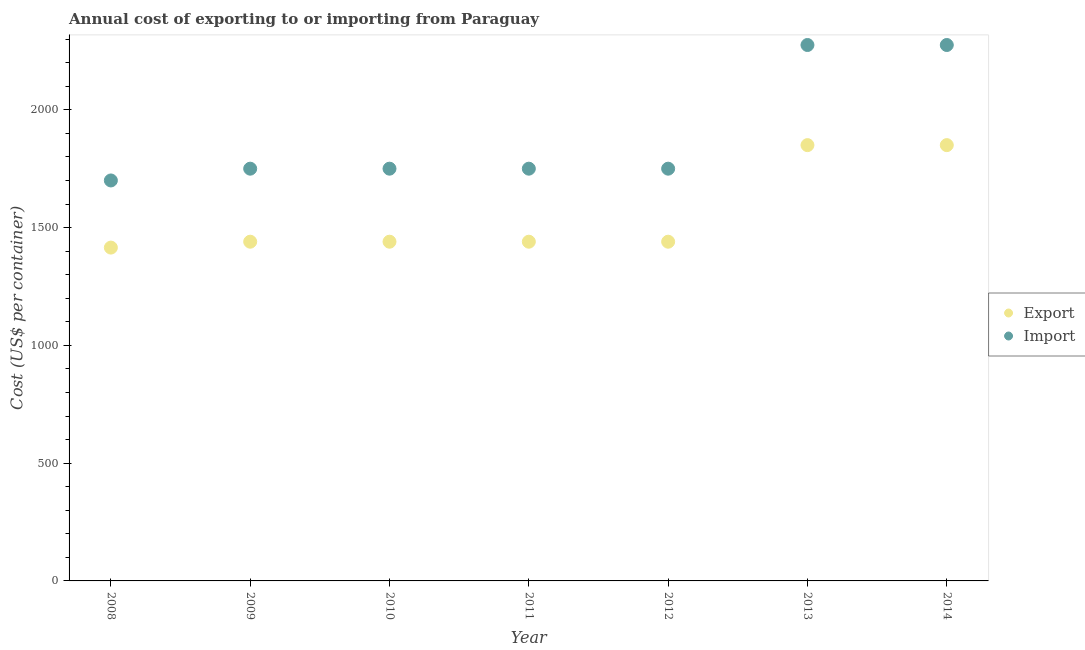Is the number of dotlines equal to the number of legend labels?
Your answer should be compact. Yes. What is the export cost in 2008?
Ensure brevity in your answer.  1415. Across all years, what is the maximum import cost?
Your answer should be compact. 2275. Across all years, what is the minimum export cost?
Provide a short and direct response. 1415. What is the total export cost in the graph?
Your answer should be compact. 1.09e+04. What is the difference between the export cost in 2008 and that in 2014?
Ensure brevity in your answer.  -435. What is the difference between the export cost in 2010 and the import cost in 2014?
Offer a terse response. -835. What is the average import cost per year?
Your answer should be compact. 1892.86. In the year 2011, what is the difference between the export cost and import cost?
Offer a very short reply. -310. What is the ratio of the export cost in 2008 to that in 2013?
Provide a succinct answer. 0.76. Is the import cost in 2009 less than that in 2011?
Ensure brevity in your answer.  No. Is the difference between the export cost in 2009 and 2013 greater than the difference between the import cost in 2009 and 2013?
Offer a very short reply. Yes. What is the difference between the highest and the second highest import cost?
Offer a terse response. 0. What is the difference between the highest and the lowest export cost?
Give a very brief answer. 435. In how many years, is the export cost greater than the average export cost taken over all years?
Your answer should be very brief. 2. Is the export cost strictly less than the import cost over the years?
Offer a very short reply. Yes. How many dotlines are there?
Make the answer very short. 2. Are the values on the major ticks of Y-axis written in scientific E-notation?
Offer a terse response. No. Does the graph contain any zero values?
Your response must be concise. No. Does the graph contain grids?
Give a very brief answer. No. Where does the legend appear in the graph?
Provide a succinct answer. Center right. How are the legend labels stacked?
Provide a short and direct response. Vertical. What is the title of the graph?
Provide a succinct answer. Annual cost of exporting to or importing from Paraguay. Does "Arms exports" appear as one of the legend labels in the graph?
Ensure brevity in your answer.  No. What is the label or title of the Y-axis?
Keep it short and to the point. Cost (US$ per container). What is the Cost (US$ per container) of Export in 2008?
Give a very brief answer. 1415. What is the Cost (US$ per container) in Import in 2008?
Provide a succinct answer. 1700. What is the Cost (US$ per container) of Export in 2009?
Offer a very short reply. 1440. What is the Cost (US$ per container) of Import in 2009?
Offer a very short reply. 1750. What is the Cost (US$ per container) in Export in 2010?
Your answer should be compact. 1440. What is the Cost (US$ per container) of Import in 2010?
Give a very brief answer. 1750. What is the Cost (US$ per container) of Export in 2011?
Provide a succinct answer. 1440. What is the Cost (US$ per container) in Import in 2011?
Your answer should be compact. 1750. What is the Cost (US$ per container) of Export in 2012?
Provide a short and direct response. 1440. What is the Cost (US$ per container) in Import in 2012?
Make the answer very short. 1750. What is the Cost (US$ per container) of Export in 2013?
Provide a short and direct response. 1850. What is the Cost (US$ per container) in Import in 2013?
Provide a short and direct response. 2275. What is the Cost (US$ per container) of Export in 2014?
Offer a terse response. 1850. What is the Cost (US$ per container) in Import in 2014?
Offer a very short reply. 2275. Across all years, what is the maximum Cost (US$ per container) of Export?
Offer a very short reply. 1850. Across all years, what is the maximum Cost (US$ per container) of Import?
Provide a succinct answer. 2275. Across all years, what is the minimum Cost (US$ per container) in Export?
Your answer should be very brief. 1415. Across all years, what is the minimum Cost (US$ per container) of Import?
Give a very brief answer. 1700. What is the total Cost (US$ per container) of Export in the graph?
Provide a short and direct response. 1.09e+04. What is the total Cost (US$ per container) of Import in the graph?
Offer a terse response. 1.32e+04. What is the difference between the Cost (US$ per container) in Import in 2008 and that in 2009?
Provide a short and direct response. -50. What is the difference between the Cost (US$ per container) of Export in 2008 and that in 2010?
Ensure brevity in your answer.  -25. What is the difference between the Cost (US$ per container) of Export in 2008 and that in 2013?
Ensure brevity in your answer.  -435. What is the difference between the Cost (US$ per container) in Import in 2008 and that in 2013?
Your answer should be compact. -575. What is the difference between the Cost (US$ per container) of Export in 2008 and that in 2014?
Ensure brevity in your answer.  -435. What is the difference between the Cost (US$ per container) in Import in 2008 and that in 2014?
Your answer should be very brief. -575. What is the difference between the Cost (US$ per container) in Export in 2009 and that in 2010?
Make the answer very short. 0. What is the difference between the Cost (US$ per container) in Import in 2009 and that in 2010?
Provide a short and direct response. 0. What is the difference between the Cost (US$ per container) in Export in 2009 and that in 2011?
Give a very brief answer. 0. What is the difference between the Cost (US$ per container) of Export in 2009 and that in 2013?
Provide a succinct answer. -410. What is the difference between the Cost (US$ per container) of Import in 2009 and that in 2013?
Make the answer very short. -525. What is the difference between the Cost (US$ per container) in Export in 2009 and that in 2014?
Your answer should be very brief. -410. What is the difference between the Cost (US$ per container) of Import in 2009 and that in 2014?
Your answer should be compact. -525. What is the difference between the Cost (US$ per container) of Import in 2010 and that in 2011?
Keep it short and to the point. 0. What is the difference between the Cost (US$ per container) in Export in 2010 and that in 2012?
Offer a very short reply. 0. What is the difference between the Cost (US$ per container) of Export in 2010 and that in 2013?
Offer a very short reply. -410. What is the difference between the Cost (US$ per container) in Import in 2010 and that in 2013?
Your answer should be very brief. -525. What is the difference between the Cost (US$ per container) of Export in 2010 and that in 2014?
Your response must be concise. -410. What is the difference between the Cost (US$ per container) in Import in 2010 and that in 2014?
Provide a succinct answer. -525. What is the difference between the Cost (US$ per container) in Export in 2011 and that in 2013?
Provide a succinct answer. -410. What is the difference between the Cost (US$ per container) in Import in 2011 and that in 2013?
Ensure brevity in your answer.  -525. What is the difference between the Cost (US$ per container) of Export in 2011 and that in 2014?
Offer a very short reply. -410. What is the difference between the Cost (US$ per container) in Import in 2011 and that in 2014?
Your answer should be compact. -525. What is the difference between the Cost (US$ per container) of Export in 2012 and that in 2013?
Give a very brief answer. -410. What is the difference between the Cost (US$ per container) of Import in 2012 and that in 2013?
Ensure brevity in your answer.  -525. What is the difference between the Cost (US$ per container) in Export in 2012 and that in 2014?
Provide a short and direct response. -410. What is the difference between the Cost (US$ per container) of Import in 2012 and that in 2014?
Offer a very short reply. -525. What is the difference between the Cost (US$ per container) of Export in 2013 and that in 2014?
Provide a short and direct response. 0. What is the difference between the Cost (US$ per container) in Import in 2013 and that in 2014?
Provide a succinct answer. 0. What is the difference between the Cost (US$ per container) of Export in 2008 and the Cost (US$ per container) of Import in 2009?
Your answer should be very brief. -335. What is the difference between the Cost (US$ per container) of Export in 2008 and the Cost (US$ per container) of Import in 2010?
Make the answer very short. -335. What is the difference between the Cost (US$ per container) of Export in 2008 and the Cost (US$ per container) of Import in 2011?
Your answer should be compact. -335. What is the difference between the Cost (US$ per container) of Export in 2008 and the Cost (US$ per container) of Import in 2012?
Offer a terse response. -335. What is the difference between the Cost (US$ per container) of Export in 2008 and the Cost (US$ per container) of Import in 2013?
Make the answer very short. -860. What is the difference between the Cost (US$ per container) in Export in 2008 and the Cost (US$ per container) in Import in 2014?
Give a very brief answer. -860. What is the difference between the Cost (US$ per container) of Export in 2009 and the Cost (US$ per container) of Import in 2010?
Ensure brevity in your answer.  -310. What is the difference between the Cost (US$ per container) of Export in 2009 and the Cost (US$ per container) of Import in 2011?
Give a very brief answer. -310. What is the difference between the Cost (US$ per container) in Export in 2009 and the Cost (US$ per container) in Import in 2012?
Give a very brief answer. -310. What is the difference between the Cost (US$ per container) of Export in 2009 and the Cost (US$ per container) of Import in 2013?
Offer a terse response. -835. What is the difference between the Cost (US$ per container) of Export in 2009 and the Cost (US$ per container) of Import in 2014?
Your answer should be very brief. -835. What is the difference between the Cost (US$ per container) in Export in 2010 and the Cost (US$ per container) in Import in 2011?
Your response must be concise. -310. What is the difference between the Cost (US$ per container) of Export in 2010 and the Cost (US$ per container) of Import in 2012?
Offer a very short reply. -310. What is the difference between the Cost (US$ per container) in Export in 2010 and the Cost (US$ per container) in Import in 2013?
Keep it short and to the point. -835. What is the difference between the Cost (US$ per container) of Export in 2010 and the Cost (US$ per container) of Import in 2014?
Give a very brief answer. -835. What is the difference between the Cost (US$ per container) in Export in 2011 and the Cost (US$ per container) in Import in 2012?
Ensure brevity in your answer.  -310. What is the difference between the Cost (US$ per container) in Export in 2011 and the Cost (US$ per container) in Import in 2013?
Provide a short and direct response. -835. What is the difference between the Cost (US$ per container) of Export in 2011 and the Cost (US$ per container) of Import in 2014?
Your answer should be very brief. -835. What is the difference between the Cost (US$ per container) in Export in 2012 and the Cost (US$ per container) in Import in 2013?
Your answer should be very brief. -835. What is the difference between the Cost (US$ per container) in Export in 2012 and the Cost (US$ per container) in Import in 2014?
Offer a terse response. -835. What is the difference between the Cost (US$ per container) in Export in 2013 and the Cost (US$ per container) in Import in 2014?
Offer a very short reply. -425. What is the average Cost (US$ per container) in Export per year?
Ensure brevity in your answer.  1553.57. What is the average Cost (US$ per container) of Import per year?
Ensure brevity in your answer.  1892.86. In the year 2008, what is the difference between the Cost (US$ per container) in Export and Cost (US$ per container) in Import?
Provide a short and direct response. -285. In the year 2009, what is the difference between the Cost (US$ per container) in Export and Cost (US$ per container) in Import?
Your answer should be compact. -310. In the year 2010, what is the difference between the Cost (US$ per container) in Export and Cost (US$ per container) in Import?
Ensure brevity in your answer.  -310. In the year 2011, what is the difference between the Cost (US$ per container) in Export and Cost (US$ per container) in Import?
Give a very brief answer. -310. In the year 2012, what is the difference between the Cost (US$ per container) in Export and Cost (US$ per container) in Import?
Keep it short and to the point. -310. In the year 2013, what is the difference between the Cost (US$ per container) of Export and Cost (US$ per container) of Import?
Offer a very short reply. -425. In the year 2014, what is the difference between the Cost (US$ per container) of Export and Cost (US$ per container) of Import?
Your answer should be very brief. -425. What is the ratio of the Cost (US$ per container) of Export in 2008 to that in 2009?
Keep it short and to the point. 0.98. What is the ratio of the Cost (US$ per container) in Import in 2008 to that in 2009?
Offer a very short reply. 0.97. What is the ratio of the Cost (US$ per container) in Export in 2008 to that in 2010?
Your response must be concise. 0.98. What is the ratio of the Cost (US$ per container) in Import in 2008 to that in 2010?
Your response must be concise. 0.97. What is the ratio of the Cost (US$ per container) in Export in 2008 to that in 2011?
Your response must be concise. 0.98. What is the ratio of the Cost (US$ per container) in Import in 2008 to that in 2011?
Provide a succinct answer. 0.97. What is the ratio of the Cost (US$ per container) of Export in 2008 to that in 2012?
Offer a terse response. 0.98. What is the ratio of the Cost (US$ per container) in Import in 2008 to that in 2012?
Your answer should be compact. 0.97. What is the ratio of the Cost (US$ per container) of Export in 2008 to that in 2013?
Make the answer very short. 0.76. What is the ratio of the Cost (US$ per container) of Import in 2008 to that in 2013?
Your answer should be very brief. 0.75. What is the ratio of the Cost (US$ per container) of Export in 2008 to that in 2014?
Provide a short and direct response. 0.76. What is the ratio of the Cost (US$ per container) of Import in 2008 to that in 2014?
Provide a succinct answer. 0.75. What is the ratio of the Cost (US$ per container) in Import in 2009 to that in 2011?
Provide a succinct answer. 1. What is the ratio of the Cost (US$ per container) of Import in 2009 to that in 2012?
Provide a short and direct response. 1. What is the ratio of the Cost (US$ per container) of Export in 2009 to that in 2013?
Provide a short and direct response. 0.78. What is the ratio of the Cost (US$ per container) in Import in 2009 to that in 2013?
Make the answer very short. 0.77. What is the ratio of the Cost (US$ per container) of Export in 2009 to that in 2014?
Provide a succinct answer. 0.78. What is the ratio of the Cost (US$ per container) of Import in 2009 to that in 2014?
Keep it short and to the point. 0.77. What is the ratio of the Cost (US$ per container) in Export in 2010 to that in 2011?
Your answer should be very brief. 1. What is the ratio of the Cost (US$ per container) of Export in 2010 to that in 2012?
Your answer should be very brief. 1. What is the ratio of the Cost (US$ per container) in Export in 2010 to that in 2013?
Provide a short and direct response. 0.78. What is the ratio of the Cost (US$ per container) in Import in 2010 to that in 2013?
Your response must be concise. 0.77. What is the ratio of the Cost (US$ per container) of Export in 2010 to that in 2014?
Make the answer very short. 0.78. What is the ratio of the Cost (US$ per container) in Import in 2010 to that in 2014?
Offer a terse response. 0.77. What is the ratio of the Cost (US$ per container) in Export in 2011 to that in 2012?
Give a very brief answer. 1. What is the ratio of the Cost (US$ per container) in Export in 2011 to that in 2013?
Give a very brief answer. 0.78. What is the ratio of the Cost (US$ per container) in Import in 2011 to that in 2013?
Your response must be concise. 0.77. What is the ratio of the Cost (US$ per container) of Export in 2011 to that in 2014?
Your response must be concise. 0.78. What is the ratio of the Cost (US$ per container) in Import in 2011 to that in 2014?
Provide a short and direct response. 0.77. What is the ratio of the Cost (US$ per container) in Export in 2012 to that in 2013?
Give a very brief answer. 0.78. What is the ratio of the Cost (US$ per container) of Import in 2012 to that in 2013?
Provide a succinct answer. 0.77. What is the ratio of the Cost (US$ per container) of Export in 2012 to that in 2014?
Make the answer very short. 0.78. What is the ratio of the Cost (US$ per container) in Import in 2012 to that in 2014?
Your answer should be very brief. 0.77. What is the ratio of the Cost (US$ per container) of Import in 2013 to that in 2014?
Your answer should be compact. 1. What is the difference between the highest and the second highest Cost (US$ per container) in Export?
Offer a very short reply. 0. What is the difference between the highest and the second highest Cost (US$ per container) in Import?
Your response must be concise. 0. What is the difference between the highest and the lowest Cost (US$ per container) in Export?
Your answer should be very brief. 435. What is the difference between the highest and the lowest Cost (US$ per container) in Import?
Give a very brief answer. 575. 